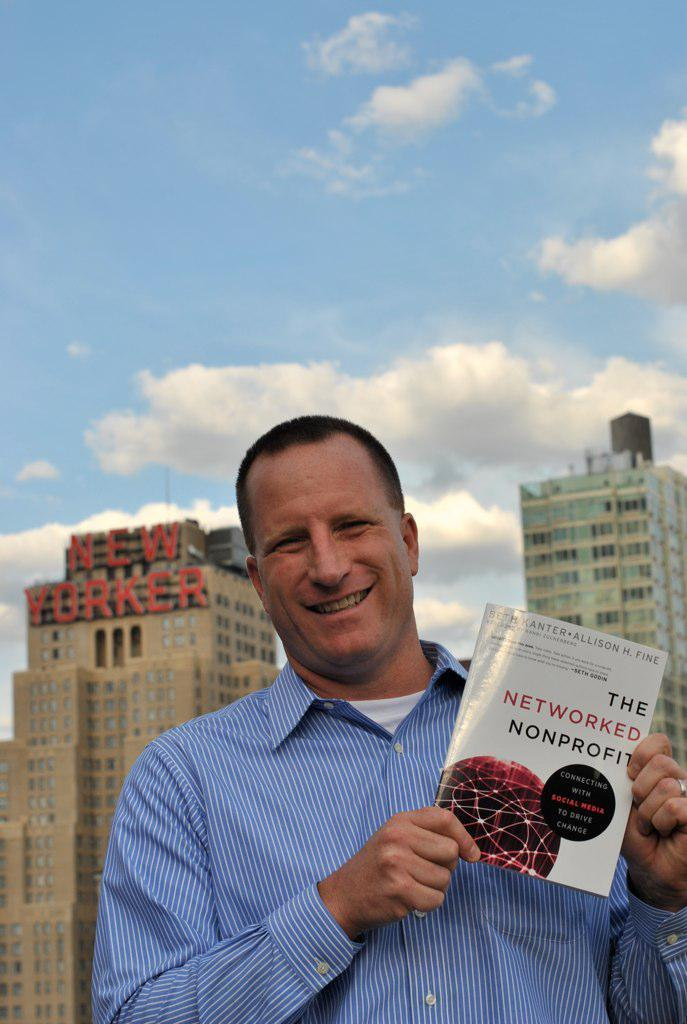<image>
Write a terse but informative summary of the picture. A man in a blue striped shirt is holding a book called The Networked Nonprofit. 